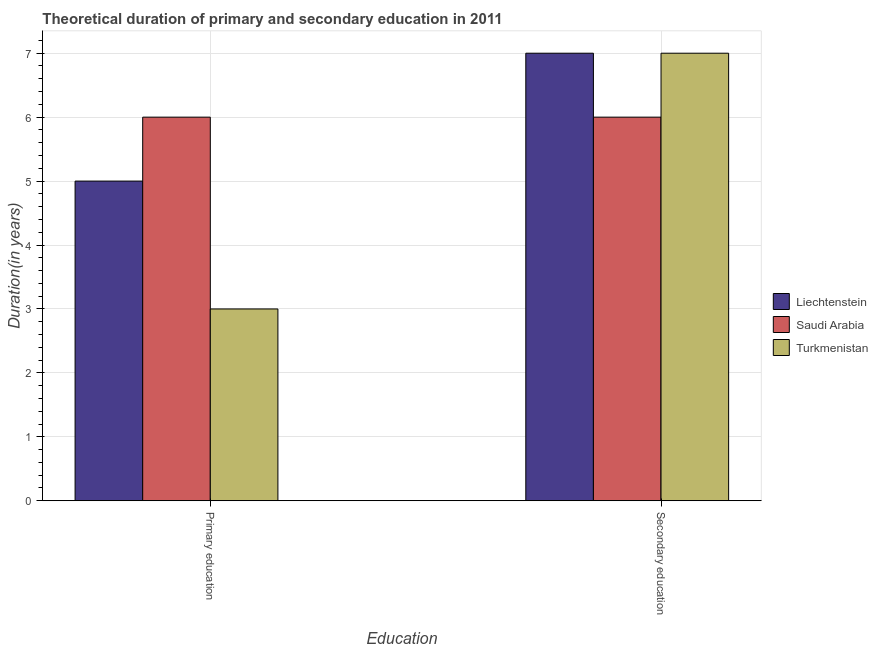How many different coloured bars are there?
Ensure brevity in your answer.  3. How many bars are there on the 2nd tick from the left?
Provide a succinct answer. 3. How many bars are there on the 2nd tick from the right?
Your answer should be compact. 3. What is the duration of primary education in Liechtenstein?
Your answer should be very brief. 5. Across all countries, what is the maximum duration of primary education?
Offer a terse response. 6. Across all countries, what is the minimum duration of primary education?
Provide a succinct answer. 3. In which country was the duration of secondary education maximum?
Your answer should be compact. Liechtenstein. In which country was the duration of secondary education minimum?
Keep it short and to the point. Saudi Arabia. What is the total duration of primary education in the graph?
Keep it short and to the point. 14. What is the difference between the duration of primary education in Turkmenistan and the duration of secondary education in Saudi Arabia?
Provide a succinct answer. -3. What is the average duration of secondary education per country?
Your response must be concise. 6.67. What is the ratio of the duration of secondary education in Turkmenistan to that in Saudi Arabia?
Ensure brevity in your answer.  1.17. In how many countries, is the duration of primary education greater than the average duration of primary education taken over all countries?
Offer a very short reply. 2. What does the 2nd bar from the left in Secondary education represents?
Provide a succinct answer. Saudi Arabia. What does the 3rd bar from the right in Primary education represents?
Ensure brevity in your answer.  Liechtenstein. How many bars are there?
Offer a very short reply. 6. Are all the bars in the graph horizontal?
Provide a succinct answer. No. Are the values on the major ticks of Y-axis written in scientific E-notation?
Keep it short and to the point. No. Does the graph contain any zero values?
Your answer should be compact. No. Where does the legend appear in the graph?
Your answer should be compact. Center right. How many legend labels are there?
Your answer should be very brief. 3. How are the legend labels stacked?
Provide a short and direct response. Vertical. What is the title of the graph?
Make the answer very short. Theoretical duration of primary and secondary education in 2011. What is the label or title of the X-axis?
Give a very brief answer. Education. What is the label or title of the Y-axis?
Ensure brevity in your answer.  Duration(in years). What is the Duration(in years) in Saudi Arabia in Primary education?
Your response must be concise. 6. What is the Duration(in years) of Liechtenstein in Secondary education?
Provide a short and direct response. 7. What is the Duration(in years) of Saudi Arabia in Secondary education?
Make the answer very short. 6. Across all Education, what is the maximum Duration(in years) in Turkmenistan?
Make the answer very short. 7. What is the total Duration(in years) in Liechtenstein in the graph?
Your response must be concise. 12. What is the total Duration(in years) of Turkmenistan in the graph?
Give a very brief answer. 10. What is the difference between the Duration(in years) in Turkmenistan in Primary education and that in Secondary education?
Provide a succinct answer. -4. What is the difference between the Duration(in years) in Liechtenstein in Primary education and the Duration(in years) in Turkmenistan in Secondary education?
Your answer should be compact. -2. What is the average Duration(in years) in Turkmenistan per Education?
Ensure brevity in your answer.  5. What is the difference between the Duration(in years) of Liechtenstein and Duration(in years) of Saudi Arabia in Primary education?
Provide a short and direct response. -1. What is the difference between the Duration(in years) of Liechtenstein and Duration(in years) of Saudi Arabia in Secondary education?
Your answer should be very brief. 1. What is the ratio of the Duration(in years) of Turkmenistan in Primary education to that in Secondary education?
Offer a very short reply. 0.43. What is the difference between the highest and the second highest Duration(in years) in Turkmenistan?
Provide a succinct answer. 4. What is the difference between the highest and the lowest Duration(in years) of Saudi Arabia?
Offer a terse response. 0. What is the difference between the highest and the lowest Duration(in years) in Turkmenistan?
Ensure brevity in your answer.  4. 